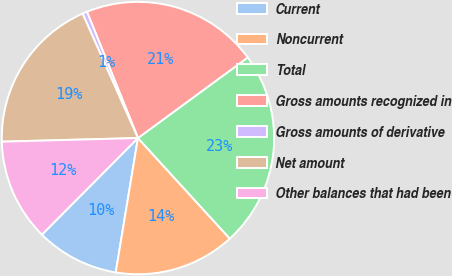<chart> <loc_0><loc_0><loc_500><loc_500><pie_chart><fcel>Current<fcel>Noncurrent<fcel>Total<fcel>Gross amounts recognized in<fcel>Gross amounts of derivative<fcel>Net amount<fcel>Other balances that had been<nl><fcel>9.85%<fcel>14.39%<fcel>23.3%<fcel>21.03%<fcel>0.56%<fcel>18.76%<fcel>12.12%<nl></chart> 